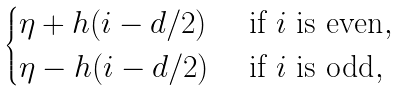Convert formula to latex. <formula><loc_0><loc_0><loc_500><loc_500>\begin{cases} \eta + h ( i - d / 2 ) & \text { if $i$ is even} , \\ \eta - h ( i - d / 2 ) & \text { if $i$ is odd} , \end{cases}</formula> 